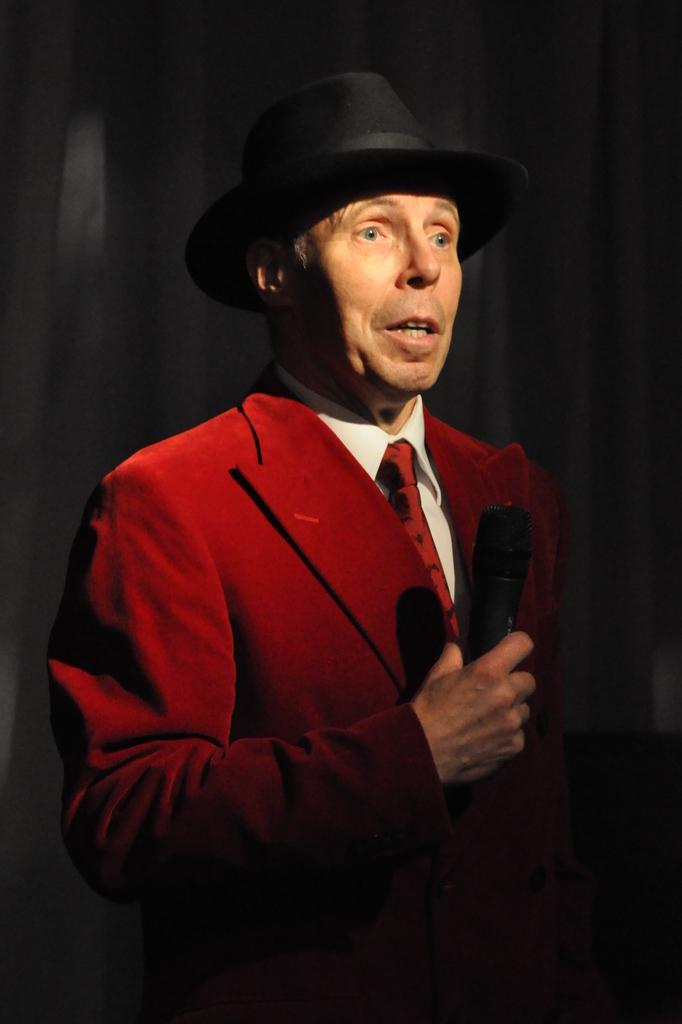What is the man in the image doing? The man is talking into a microphone. What is the man wearing on his upper body? The man is wearing a red coat, a tie, and a white shirt. What type of headwear is the man wearing? The man is wearing a black hat. How many chickens are visible in the image? There are no chickens present in the image. What type of lift is the man using to reach the microphone? The image does not show the man using a lift to reach the microphone; he is standing on the ground. 